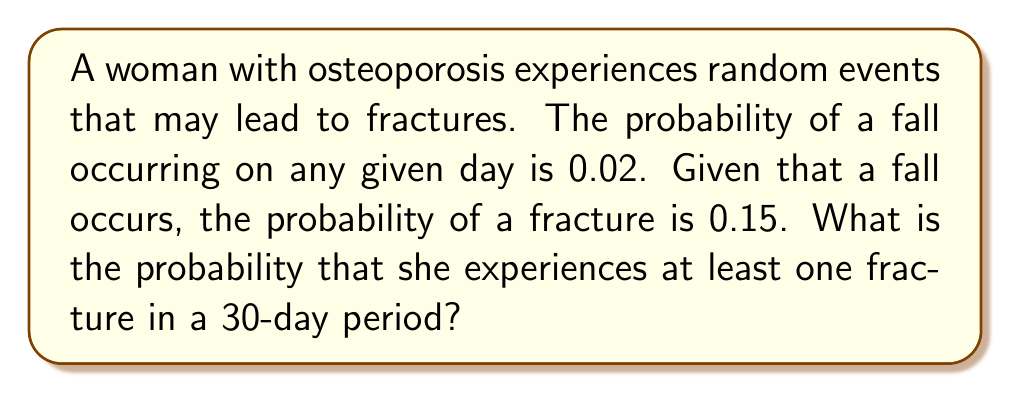Teach me how to tackle this problem. Let's approach this step-by-step using the principles of stochastic processes:

1) First, let's calculate the probability of a fracture occurring on any given day:
   $P(\text{fracture}) = P(\text{fall}) \times P(\text{fracture|fall}) = 0.02 \times 0.15 = 0.003$

2) Now, we need to find the probability of at least one fracture in 30 days. It's easier to calculate the probability of no fractures and then subtract from 1:

   $P(\text{at least one fracture}) = 1 - P(\text{no fractures})$

3) The probability of no fractures on a single day is:
   $P(\text{no fracture}) = 1 - 0.003 = 0.997$

4) For no fractures to occur in 30 days, we need this to happen 30 times in a row. Assuming independence of events:

   $P(\text{no fractures in 30 days}) = (0.997)^{30}$

5) We can calculate this:
   $(0.997)^{30} \approx 0.9139$

6) Therefore, the probability of at least one fracture in 30 days is:
   $P(\text{at least one fracture in 30 days}) = 1 - 0.9139 = 0.0861$

7) Converting to a percentage:
   $0.0861 \times 100\% = 8.61\%$
Answer: 8.61% 